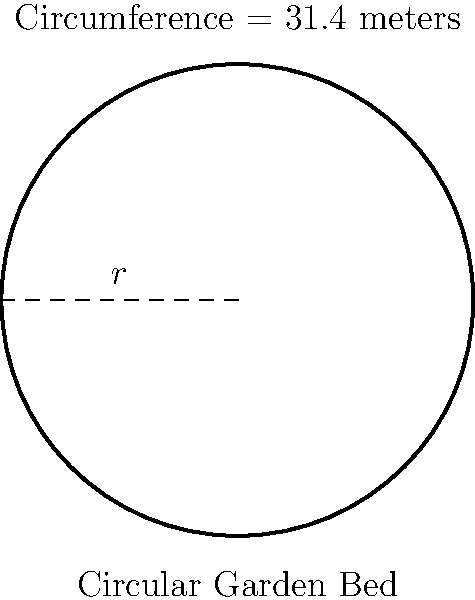Your great-grandmother's circular garden bed, as shown in her original design sketches, has a circumference of 31.4 meters. What is the radius of this garden bed? To find the radius of the circular garden bed, we can use the formula for the circumference of a circle:

$$C = 2\pi r$$

Where:
$C$ = circumference
$\pi$ = pi (approximately 3.14159)
$r$ = radius

We know the circumference is 31.4 meters, so let's plug that into our equation:

$$31.4 = 2\pi r$$

Now, we need to solve for $r$:

1) First, divide both sides by $2\pi$:

   $$\frac{31.4}{2\pi} = r$$

2) Simplify:
   
   $$r = \frac{31.4}{2\pi} \approx 5$$

3) Round to one decimal place:

   $$r \approx 5.0\text{ meters}$$

Therefore, the radius of your great-grandmother's circular garden bed is approximately 5.0 meters.
Answer: 5.0 meters 